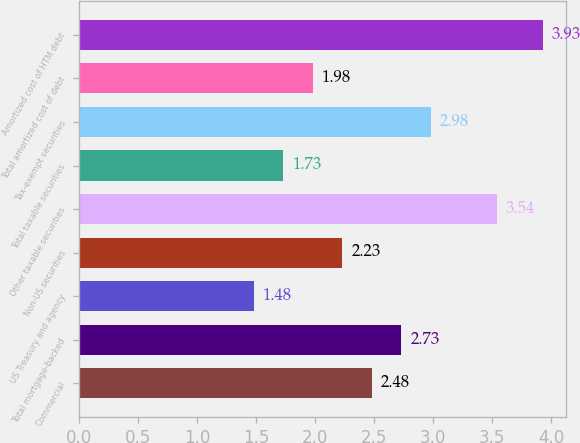Convert chart to OTSL. <chart><loc_0><loc_0><loc_500><loc_500><bar_chart><fcel>Commercial<fcel>Total mortgage-backed<fcel>US Treasury and agency<fcel>Non-US securities<fcel>Other taxable securities<fcel>Total taxable securities<fcel>Tax-exempt securities<fcel>Total amortized cost of debt<fcel>Amortized cost of HTM debt<nl><fcel>2.48<fcel>2.73<fcel>1.48<fcel>2.23<fcel>3.54<fcel>1.73<fcel>2.98<fcel>1.98<fcel>3.93<nl></chart> 